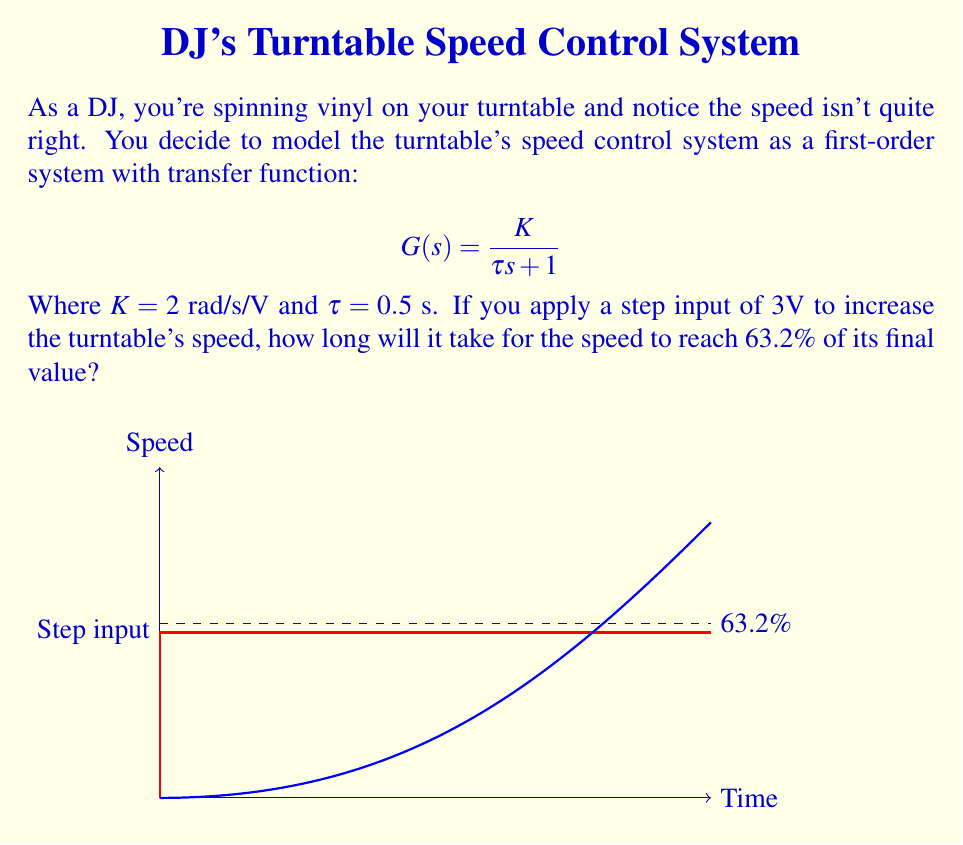Can you answer this question? Let's approach this step-by-step:

1) The transfer function given is a first-order system:
   $$G(s) = \frac{K}{\tau s + 1}$$
   Where $K = 2$ rad/s/V and $\tau = 0.5$ s

2) For a first-order system, the time constant $\tau$ represents the time it takes for the output to reach 63.2% of its final value in response to a step input.

3) In this case, $\tau$ is given directly as 0.5 seconds.

4) The magnitude of the step input (3V) and the gain $K$ don't affect the time to reach 63.2% of the final value. They only affect the final steady-state value.

5) Therefore, the time to reach 63.2% of the final value is equal to the time constant $\tau$.
Answer: 0.5 s 